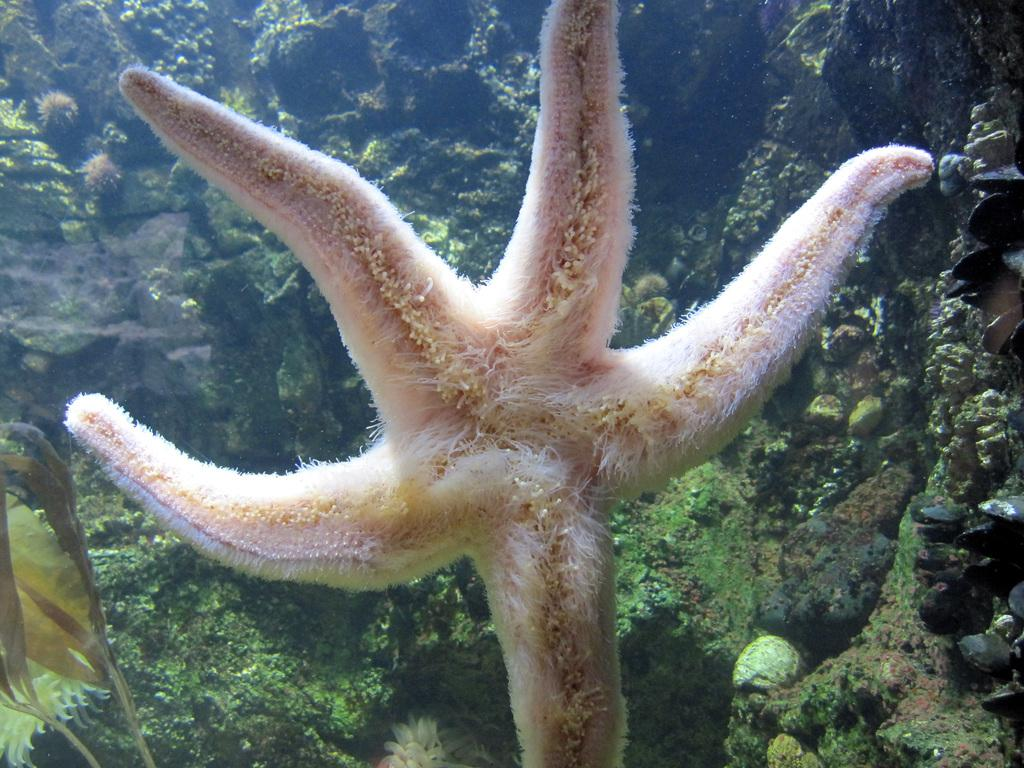What is the main subject of the image? There is a starfish in the middle of the image. What can be seen in the background of the image? There are trees and plants in the background of the image. What color is the crayon being used by the fowl in the image? There is no crayon or fowl present in the image; it features a starfish and background elements of trees and plants. 